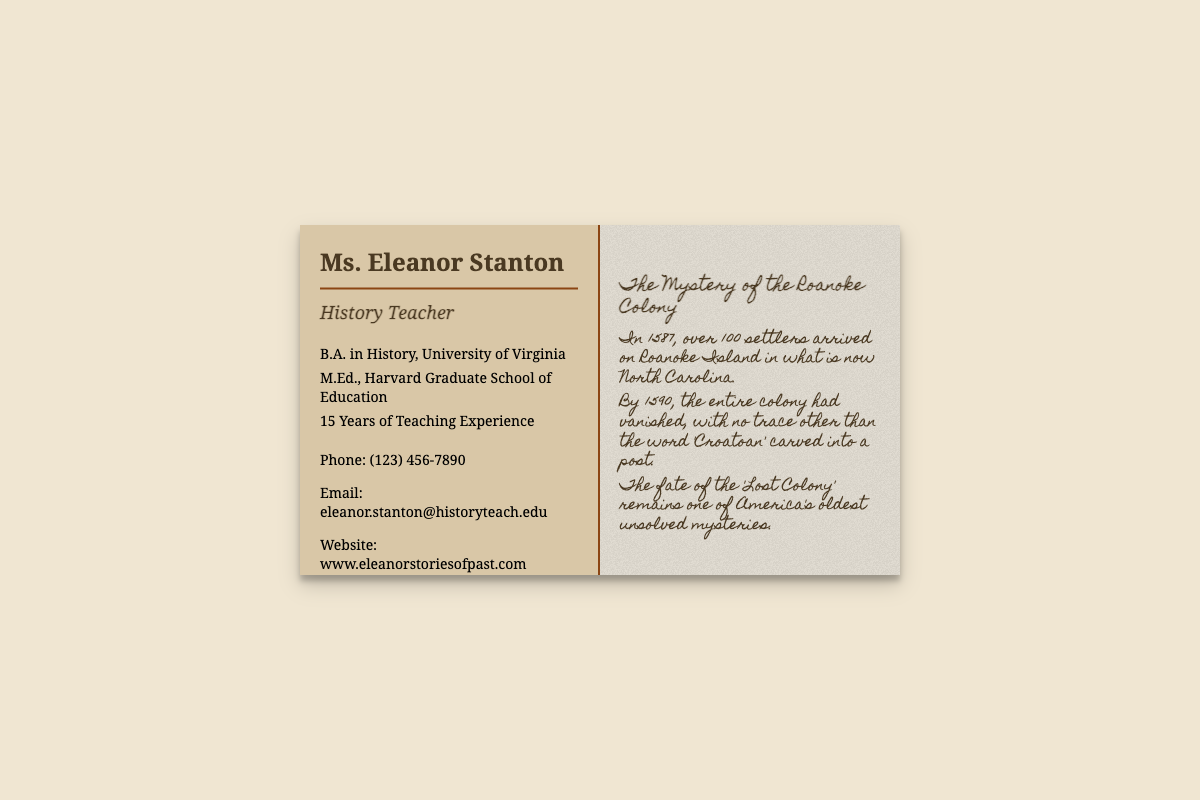What is the name of the teacher? The name of the teacher is displayed prominently at the top of the card.
Answer: Ms. Eleanor Stanton What degree does Eleanor have from the University of Virginia? This degree is listed in the qualifications section of the front side of the card.
Answer: B.A. in History How many years of teaching experience does Eleanor have? The number of teaching years is specified in the qualifications section of the card.
Answer: 15 Years What historical mystery is mentioned on the back of the card? This is the title of the historical fact presented on the back side.
Answer: The Mystery of the Roanoke Colony What word was carved into a post in the Roanoke Colony? The word is stated in the historical fact section as part of the mysterious disappearance.
Answer: Croatoan What type of card is this document? The document is recognized by its format and purpose.
Answer: Business Card How can someone contact Eleanor by phone? The contact method is outlined in the contact information section of the card.
Answer: (123) 456-7890 What is the website listed on the card? The website is part of the contact information provided on the card.
Answer: www.eleanorstoriesofpast.com What year did the settlers arrive at Roanoke Island? The year is specifically mentioned in the historical context provided in the document.
Answer: 1587 